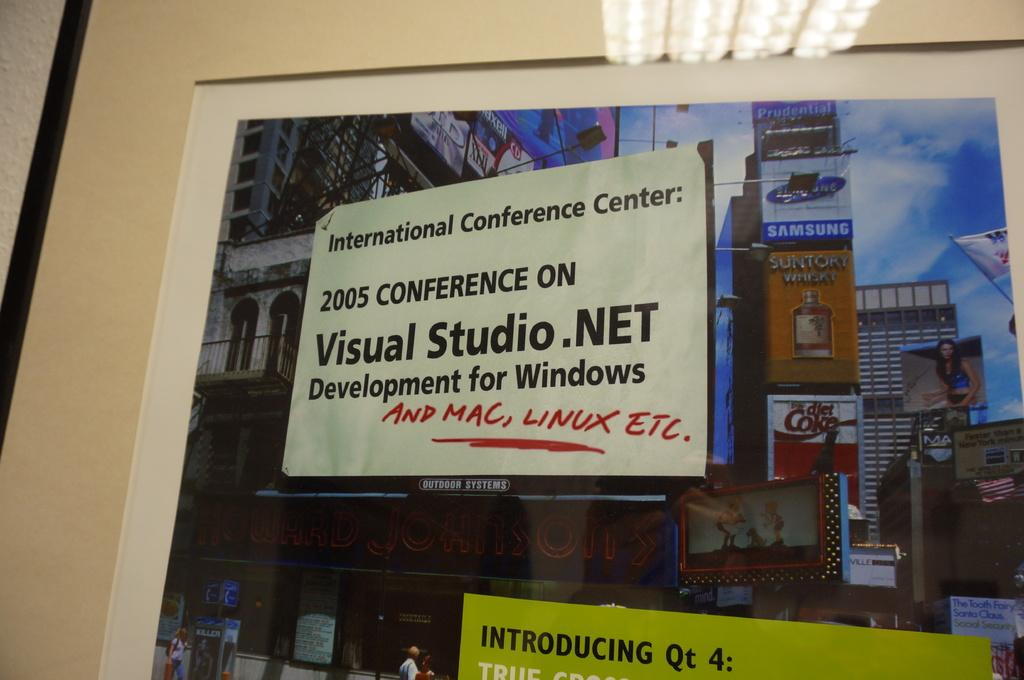<image>
Offer a succinct explanation of the picture presented. a white advertisement for visualstudios.net on the front 